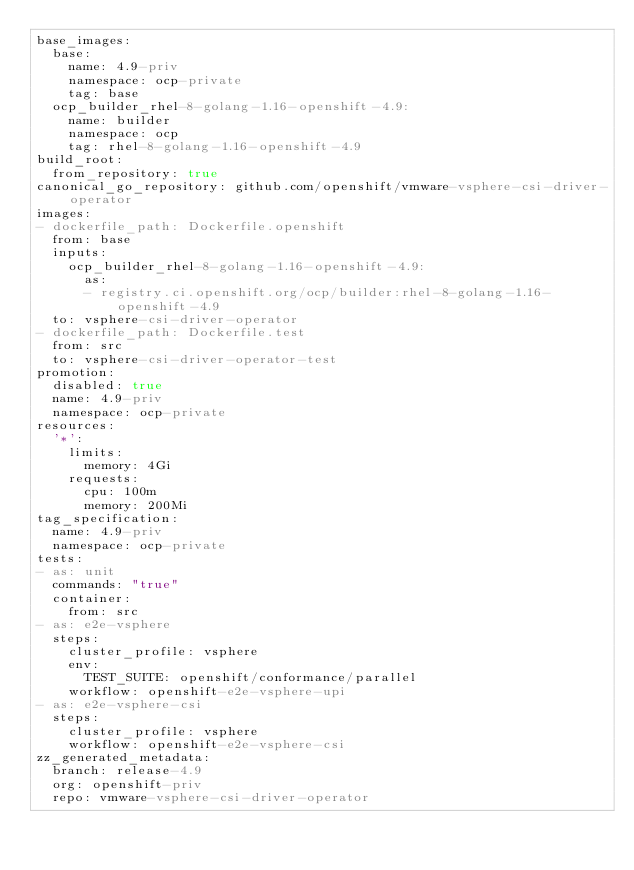Convert code to text. <code><loc_0><loc_0><loc_500><loc_500><_YAML_>base_images:
  base:
    name: 4.9-priv
    namespace: ocp-private
    tag: base
  ocp_builder_rhel-8-golang-1.16-openshift-4.9:
    name: builder
    namespace: ocp
    tag: rhel-8-golang-1.16-openshift-4.9
build_root:
  from_repository: true
canonical_go_repository: github.com/openshift/vmware-vsphere-csi-driver-operator
images:
- dockerfile_path: Dockerfile.openshift
  from: base
  inputs:
    ocp_builder_rhel-8-golang-1.16-openshift-4.9:
      as:
      - registry.ci.openshift.org/ocp/builder:rhel-8-golang-1.16-openshift-4.9
  to: vsphere-csi-driver-operator
- dockerfile_path: Dockerfile.test
  from: src
  to: vsphere-csi-driver-operator-test
promotion:
  disabled: true
  name: 4.9-priv
  namespace: ocp-private
resources:
  '*':
    limits:
      memory: 4Gi
    requests:
      cpu: 100m
      memory: 200Mi
tag_specification:
  name: 4.9-priv
  namespace: ocp-private
tests:
- as: unit
  commands: "true"
  container:
    from: src
- as: e2e-vsphere
  steps:
    cluster_profile: vsphere
    env:
      TEST_SUITE: openshift/conformance/parallel
    workflow: openshift-e2e-vsphere-upi
- as: e2e-vsphere-csi
  steps:
    cluster_profile: vsphere
    workflow: openshift-e2e-vsphere-csi
zz_generated_metadata:
  branch: release-4.9
  org: openshift-priv
  repo: vmware-vsphere-csi-driver-operator
</code> 